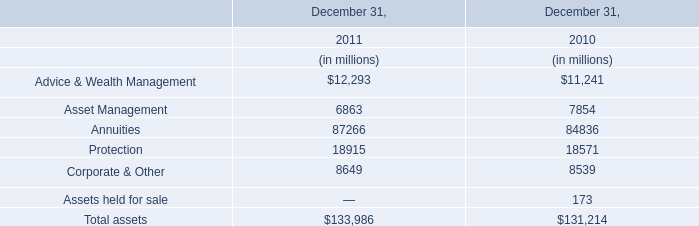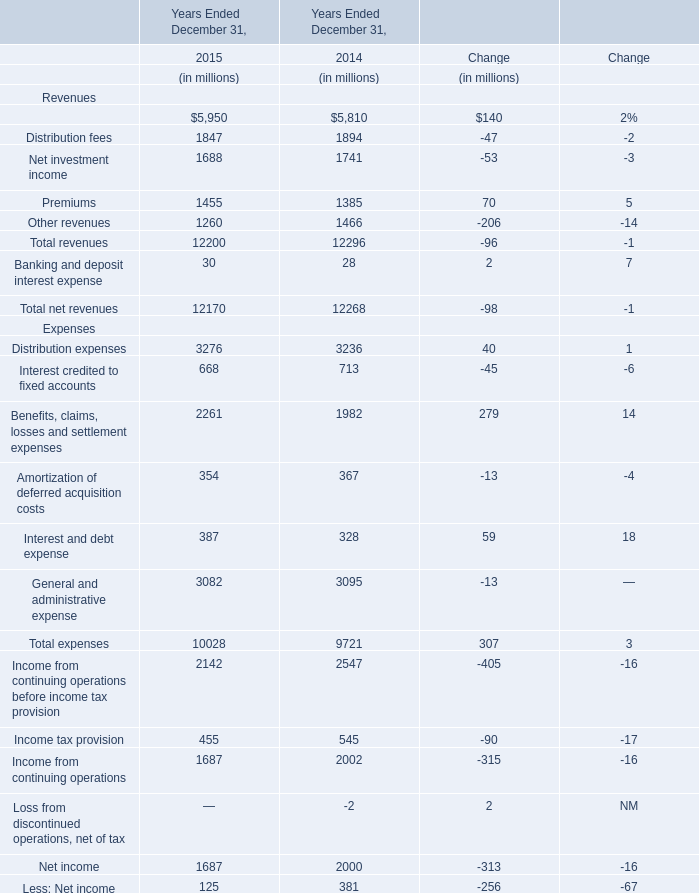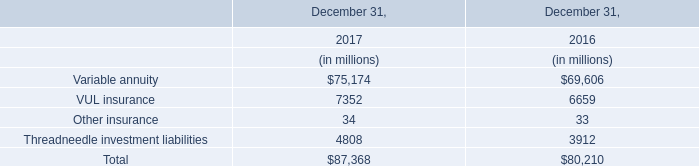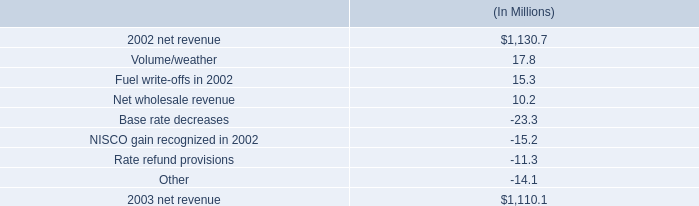what is the increase in fuel cost recovery revenues as a percentage of the change in net revenue from 2002 to 2003? 
Computations: (440.2 / (1130.7 - 1110.1))
Answer: 21.36893. 